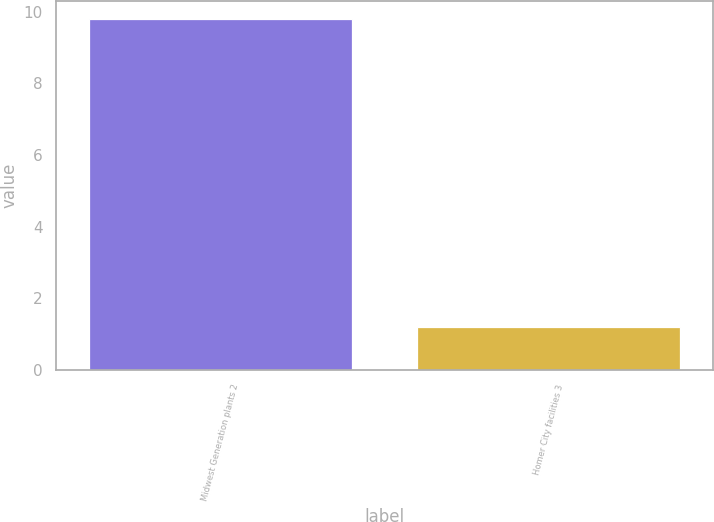Convert chart to OTSL. <chart><loc_0><loc_0><loc_500><loc_500><bar_chart><fcel>Midwest Generation plants 2<fcel>Homer City facilities 3<nl><fcel>9.8<fcel>1.2<nl></chart> 